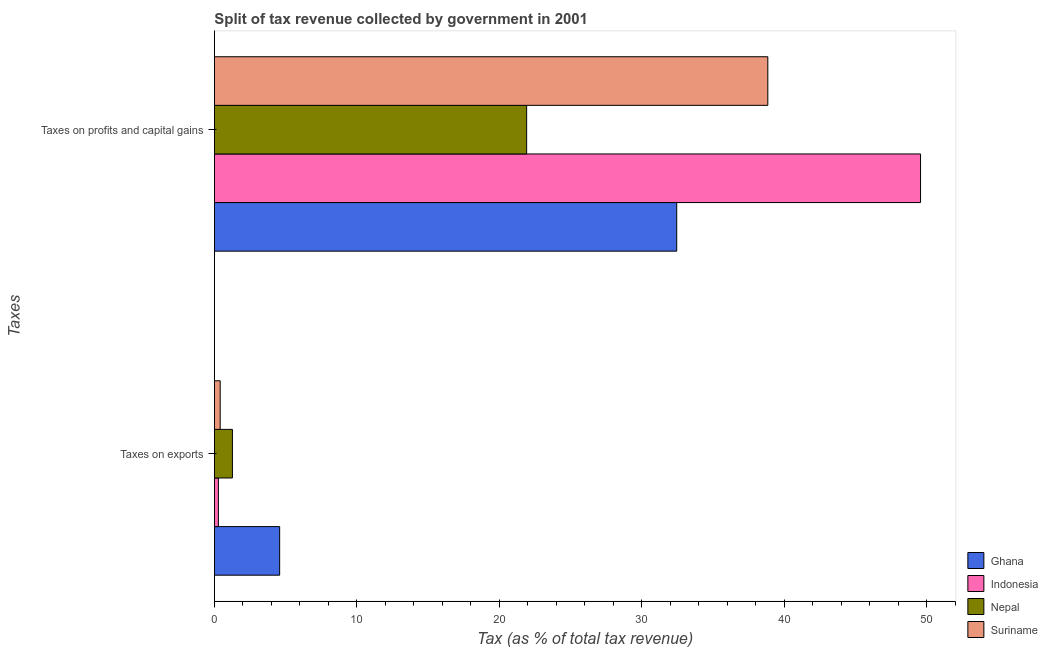How many different coloured bars are there?
Make the answer very short. 4. How many groups of bars are there?
Offer a terse response. 2. Are the number of bars per tick equal to the number of legend labels?
Ensure brevity in your answer.  Yes. Are the number of bars on each tick of the Y-axis equal?
Offer a terse response. Yes. How many bars are there on the 1st tick from the top?
Make the answer very short. 4. How many bars are there on the 2nd tick from the bottom?
Ensure brevity in your answer.  4. What is the label of the 2nd group of bars from the top?
Offer a terse response. Taxes on exports. What is the percentage of revenue obtained from taxes on profits and capital gains in Suriname?
Make the answer very short. 38.84. Across all countries, what is the maximum percentage of revenue obtained from taxes on profits and capital gains?
Make the answer very short. 49.56. Across all countries, what is the minimum percentage of revenue obtained from taxes on profits and capital gains?
Your answer should be very brief. 21.91. In which country was the percentage of revenue obtained from taxes on profits and capital gains minimum?
Provide a succinct answer. Nepal. What is the total percentage of revenue obtained from taxes on profits and capital gains in the graph?
Ensure brevity in your answer.  142.76. What is the difference between the percentage of revenue obtained from taxes on exports in Suriname and that in Nepal?
Your answer should be compact. -0.86. What is the difference between the percentage of revenue obtained from taxes on exports in Suriname and the percentage of revenue obtained from taxes on profits and capital gains in Ghana?
Make the answer very short. -32.04. What is the average percentage of revenue obtained from taxes on exports per country?
Your response must be concise. 1.64. What is the difference between the percentage of revenue obtained from taxes on profits and capital gains and percentage of revenue obtained from taxes on exports in Indonesia?
Keep it short and to the point. 49.27. In how many countries, is the percentage of revenue obtained from taxes on exports greater than 26 %?
Provide a succinct answer. 0. What is the ratio of the percentage of revenue obtained from taxes on profits and capital gains in Ghana to that in Indonesia?
Provide a short and direct response. 0.65. In how many countries, is the percentage of revenue obtained from taxes on exports greater than the average percentage of revenue obtained from taxes on exports taken over all countries?
Ensure brevity in your answer.  1. What does the 1st bar from the top in Taxes on exports represents?
Make the answer very short. Suriname. What does the 4th bar from the bottom in Taxes on profits and capital gains represents?
Ensure brevity in your answer.  Suriname. Are all the bars in the graph horizontal?
Ensure brevity in your answer.  Yes. How many countries are there in the graph?
Provide a short and direct response. 4. Does the graph contain any zero values?
Provide a short and direct response. No. Where does the legend appear in the graph?
Provide a short and direct response. Bottom right. How many legend labels are there?
Your response must be concise. 4. How are the legend labels stacked?
Give a very brief answer. Vertical. What is the title of the graph?
Keep it short and to the point. Split of tax revenue collected by government in 2001. Does "Chile" appear as one of the legend labels in the graph?
Provide a succinct answer. No. What is the label or title of the X-axis?
Offer a very short reply. Tax (as % of total tax revenue). What is the label or title of the Y-axis?
Make the answer very short. Taxes. What is the Tax (as % of total tax revenue) in Ghana in Taxes on exports?
Offer a terse response. 4.58. What is the Tax (as % of total tax revenue) in Indonesia in Taxes on exports?
Your answer should be very brief. 0.28. What is the Tax (as % of total tax revenue) of Nepal in Taxes on exports?
Offer a terse response. 1.27. What is the Tax (as % of total tax revenue) in Suriname in Taxes on exports?
Make the answer very short. 0.41. What is the Tax (as % of total tax revenue) in Ghana in Taxes on profits and capital gains?
Provide a short and direct response. 32.45. What is the Tax (as % of total tax revenue) in Indonesia in Taxes on profits and capital gains?
Provide a short and direct response. 49.56. What is the Tax (as % of total tax revenue) in Nepal in Taxes on profits and capital gains?
Make the answer very short. 21.91. What is the Tax (as % of total tax revenue) of Suriname in Taxes on profits and capital gains?
Make the answer very short. 38.84. Across all Taxes, what is the maximum Tax (as % of total tax revenue) of Ghana?
Provide a succinct answer. 32.45. Across all Taxes, what is the maximum Tax (as % of total tax revenue) of Indonesia?
Give a very brief answer. 49.56. Across all Taxes, what is the maximum Tax (as % of total tax revenue) in Nepal?
Give a very brief answer. 21.91. Across all Taxes, what is the maximum Tax (as % of total tax revenue) in Suriname?
Offer a very short reply. 38.84. Across all Taxes, what is the minimum Tax (as % of total tax revenue) of Ghana?
Your answer should be compact. 4.58. Across all Taxes, what is the minimum Tax (as % of total tax revenue) of Indonesia?
Your response must be concise. 0.28. Across all Taxes, what is the minimum Tax (as % of total tax revenue) of Nepal?
Offer a very short reply. 1.27. Across all Taxes, what is the minimum Tax (as % of total tax revenue) in Suriname?
Your response must be concise. 0.41. What is the total Tax (as % of total tax revenue) in Ghana in the graph?
Give a very brief answer. 37.03. What is the total Tax (as % of total tax revenue) in Indonesia in the graph?
Offer a terse response. 49.84. What is the total Tax (as % of total tax revenue) of Nepal in the graph?
Provide a short and direct response. 23.18. What is the total Tax (as % of total tax revenue) in Suriname in the graph?
Make the answer very short. 39.25. What is the difference between the Tax (as % of total tax revenue) in Ghana in Taxes on exports and that in Taxes on profits and capital gains?
Your answer should be very brief. -27.86. What is the difference between the Tax (as % of total tax revenue) in Indonesia in Taxes on exports and that in Taxes on profits and capital gains?
Make the answer very short. -49.27. What is the difference between the Tax (as % of total tax revenue) in Nepal in Taxes on exports and that in Taxes on profits and capital gains?
Make the answer very short. -20.65. What is the difference between the Tax (as % of total tax revenue) in Suriname in Taxes on exports and that in Taxes on profits and capital gains?
Provide a short and direct response. -38.43. What is the difference between the Tax (as % of total tax revenue) in Ghana in Taxes on exports and the Tax (as % of total tax revenue) in Indonesia in Taxes on profits and capital gains?
Provide a short and direct response. -44.97. What is the difference between the Tax (as % of total tax revenue) in Ghana in Taxes on exports and the Tax (as % of total tax revenue) in Nepal in Taxes on profits and capital gains?
Your answer should be compact. -17.33. What is the difference between the Tax (as % of total tax revenue) in Ghana in Taxes on exports and the Tax (as % of total tax revenue) in Suriname in Taxes on profits and capital gains?
Give a very brief answer. -34.26. What is the difference between the Tax (as % of total tax revenue) of Indonesia in Taxes on exports and the Tax (as % of total tax revenue) of Nepal in Taxes on profits and capital gains?
Keep it short and to the point. -21.63. What is the difference between the Tax (as % of total tax revenue) of Indonesia in Taxes on exports and the Tax (as % of total tax revenue) of Suriname in Taxes on profits and capital gains?
Keep it short and to the point. -38.55. What is the difference between the Tax (as % of total tax revenue) in Nepal in Taxes on exports and the Tax (as % of total tax revenue) in Suriname in Taxes on profits and capital gains?
Provide a succinct answer. -37.57. What is the average Tax (as % of total tax revenue) in Ghana per Taxes?
Offer a terse response. 18.51. What is the average Tax (as % of total tax revenue) in Indonesia per Taxes?
Offer a very short reply. 24.92. What is the average Tax (as % of total tax revenue) of Nepal per Taxes?
Give a very brief answer. 11.59. What is the average Tax (as % of total tax revenue) of Suriname per Taxes?
Provide a short and direct response. 19.62. What is the difference between the Tax (as % of total tax revenue) in Ghana and Tax (as % of total tax revenue) in Indonesia in Taxes on exports?
Offer a very short reply. 4.3. What is the difference between the Tax (as % of total tax revenue) in Ghana and Tax (as % of total tax revenue) in Nepal in Taxes on exports?
Your response must be concise. 3.31. What is the difference between the Tax (as % of total tax revenue) in Ghana and Tax (as % of total tax revenue) in Suriname in Taxes on exports?
Your response must be concise. 4.17. What is the difference between the Tax (as % of total tax revenue) in Indonesia and Tax (as % of total tax revenue) in Nepal in Taxes on exports?
Provide a succinct answer. -0.98. What is the difference between the Tax (as % of total tax revenue) in Indonesia and Tax (as % of total tax revenue) in Suriname in Taxes on exports?
Keep it short and to the point. -0.13. What is the difference between the Tax (as % of total tax revenue) of Nepal and Tax (as % of total tax revenue) of Suriname in Taxes on exports?
Your response must be concise. 0.86. What is the difference between the Tax (as % of total tax revenue) of Ghana and Tax (as % of total tax revenue) of Indonesia in Taxes on profits and capital gains?
Keep it short and to the point. -17.11. What is the difference between the Tax (as % of total tax revenue) in Ghana and Tax (as % of total tax revenue) in Nepal in Taxes on profits and capital gains?
Your answer should be very brief. 10.53. What is the difference between the Tax (as % of total tax revenue) in Ghana and Tax (as % of total tax revenue) in Suriname in Taxes on profits and capital gains?
Give a very brief answer. -6.39. What is the difference between the Tax (as % of total tax revenue) of Indonesia and Tax (as % of total tax revenue) of Nepal in Taxes on profits and capital gains?
Provide a short and direct response. 27.64. What is the difference between the Tax (as % of total tax revenue) in Indonesia and Tax (as % of total tax revenue) in Suriname in Taxes on profits and capital gains?
Your answer should be very brief. 10.72. What is the difference between the Tax (as % of total tax revenue) in Nepal and Tax (as % of total tax revenue) in Suriname in Taxes on profits and capital gains?
Ensure brevity in your answer.  -16.92. What is the ratio of the Tax (as % of total tax revenue) in Ghana in Taxes on exports to that in Taxes on profits and capital gains?
Your answer should be compact. 0.14. What is the ratio of the Tax (as % of total tax revenue) of Indonesia in Taxes on exports to that in Taxes on profits and capital gains?
Offer a terse response. 0.01. What is the ratio of the Tax (as % of total tax revenue) of Nepal in Taxes on exports to that in Taxes on profits and capital gains?
Provide a succinct answer. 0.06. What is the ratio of the Tax (as % of total tax revenue) of Suriname in Taxes on exports to that in Taxes on profits and capital gains?
Keep it short and to the point. 0.01. What is the difference between the highest and the second highest Tax (as % of total tax revenue) of Ghana?
Provide a succinct answer. 27.86. What is the difference between the highest and the second highest Tax (as % of total tax revenue) of Indonesia?
Ensure brevity in your answer.  49.27. What is the difference between the highest and the second highest Tax (as % of total tax revenue) in Nepal?
Keep it short and to the point. 20.65. What is the difference between the highest and the second highest Tax (as % of total tax revenue) of Suriname?
Your answer should be compact. 38.43. What is the difference between the highest and the lowest Tax (as % of total tax revenue) of Ghana?
Provide a succinct answer. 27.86. What is the difference between the highest and the lowest Tax (as % of total tax revenue) of Indonesia?
Ensure brevity in your answer.  49.27. What is the difference between the highest and the lowest Tax (as % of total tax revenue) of Nepal?
Give a very brief answer. 20.65. What is the difference between the highest and the lowest Tax (as % of total tax revenue) of Suriname?
Your response must be concise. 38.43. 